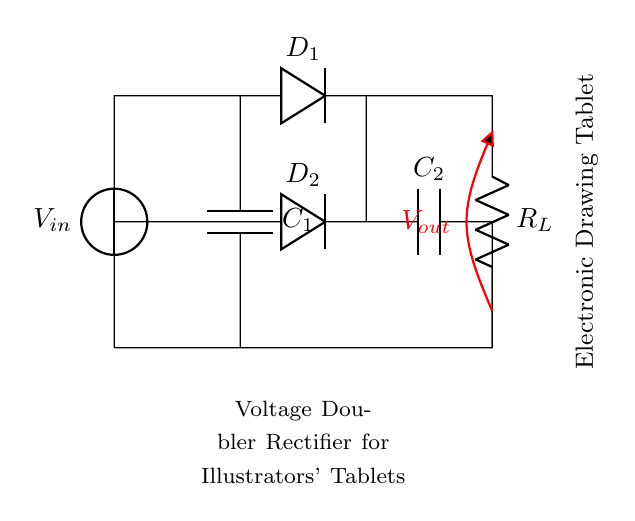What components are in the circuit? The circuit includes a voltage source, two diodes (D1 and D2), two capacitors (C1 and C2), and a load resistor (R_L). These components are essential for the operation of a voltage doubler rectifier circuit.
Answer: voltage source, D1, D2, C1, C2, R_L What is the role of the diodes in the circuit? The diodes (D1 and D2) allow current to flow in one direction only, which is crucial for rectification. In this circuit, they work together to ensure that the voltage is doubled by directing current through the capacitors in a specific manner.
Answer: rectification How many capacitors are present, and what are their labels? There are two capacitors labeled C1 and C2. The function of each capacitor is to store charge, contributing to the voltage-doubling effect of the rectifier.
Answer: two, C1 and C2 What is the output voltage of this rectifier circuit compared to the input voltage? The circuit is designed to double the input voltage across the load resistor. Therefore, if the input voltage is V_in, the output voltage (V_out) will be approximately 2 times V_in. This is a key characteristic of a voltage doubler rectifier circuit.
Answer: 2 times V_in What type of circuit is this? This is a voltage doubler rectifier circuit, specifically designed for use in electronic drawing tablets. It converts an AC input into a higher DC output, which is essential for the operation of devices that require stable voltage for drawing applications.
Answer: voltage doubler rectifier 